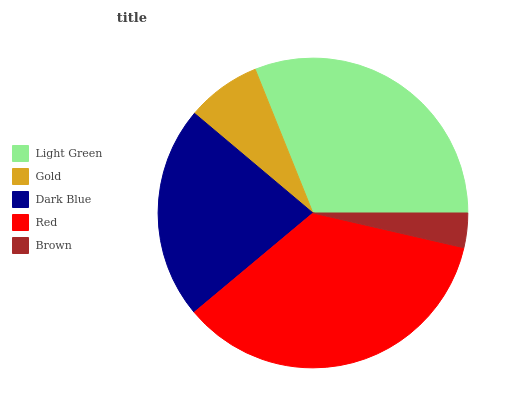Is Brown the minimum?
Answer yes or no. Yes. Is Red the maximum?
Answer yes or no. Yes. Is Gold the minimum?
Answer yes or no. No. Is Gold the maximum?
Answer yes or no. No. Is Light Green greater than Gold?
Answer yes or no. Yes. Is Gold less than Light Green?
Answer yes or no. Yes. Is Gold greater than Light Green?
Answer yes or no. No. Is Light Green less than Gold?
Answer yes or no. No. Is Dark Blue the high median?
Answer yes or no. Yes. Is Dark Blue the low median?
Answer yes or no. Yes. Is Gold the high median?
Answer yes or no. No. Is Light Green the low median?
Answer yes or no. No. 